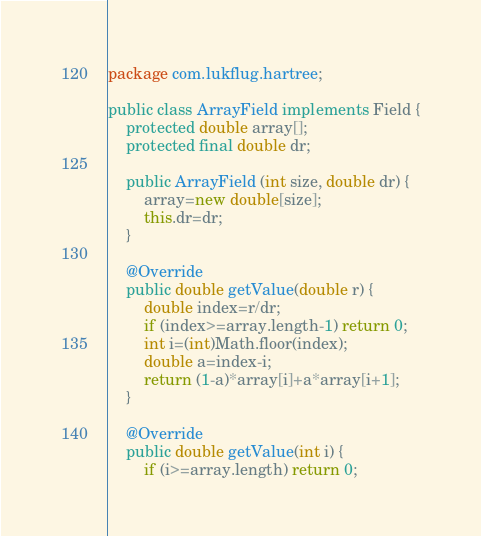<code> <loc_0><loc_0><loc_500><loc_500><_Java_>package com.lukflug.hartree;

public class ArrayField implements Field {
	protected double array[];
	protected final double dr;

	public ArrayField (int size, double dr) {
		array=new double[size];
		this.dr=dr;
	}

	@Override
	public double getValue(double r) {
		double index=r/dr;
		if (index>=array.length-1) return 0;
		int i=(int)Math.floor(index);
		double a=index-i;
		return (1-a)*array[i]+a*array[i+1];
	}
	
	@Override
	public double getValue(int i) {
		if (i>=array.length) return 0;</code> 